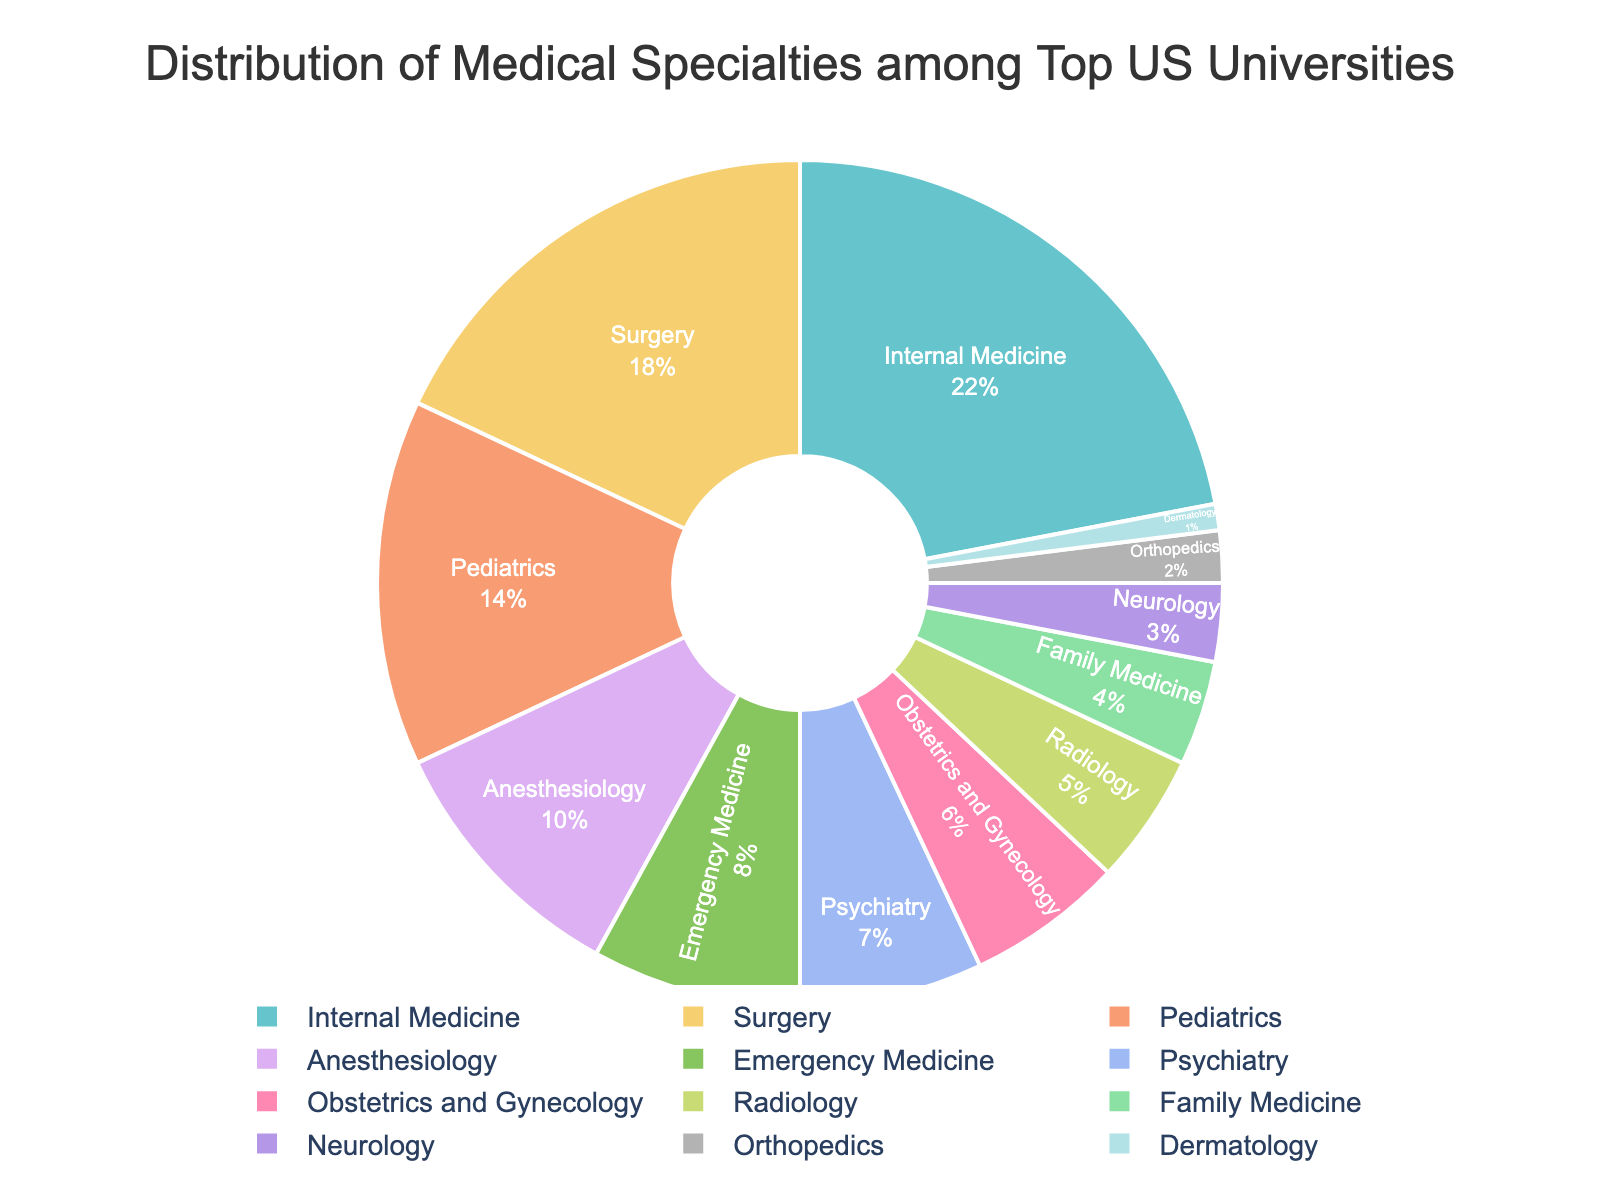Which specialty has the largest representation in the pie chart? The slice of the pie chart labeled "Internal Medicine" is the largest.
Answer: Internal Medicine What is the combined percentage representation of Pediatrics and Anesthesiology specialties? Pediatrics is 14% and Anesthesiology is 10%. Summing these percentages: 14% + 10% = 24%.
Answer: 24% How does the representation of Surgery compare to that of Emergency Medicine? The slice labeled "Surgery" is 18%, while "Emergency Medicine" is 8%. Comparing the two: 18% is greater than 8%.
Answer: Surgery is greater than Emergency Medicine What is the difference in percentage between the most and least represented specialties? Internal Medicine is the most represented at 22%, and Dermatology is the least represented at 1%. The difference is 22% - 1% = 21%.
Answer: 21% Which specialty occupies a bigger portion of the pie, Radiology or Psychiatry? The slice labeled "Psychiatry" is 7%, while "Radiology" is 5%. Comparing the two: 7% is greater than 5%.
Answer: Psychiatry If you combined the percentages of Family Medicine and Neurology, would it be greater than the percentage for Pediatrics? Family Medicine is 4% and Neurology is 3%, combining these: 4% + 3% = 7%. Pediatrics is 14%. Comparing the sums: 7% is less than 14%.
Answer: No What percentage of specialties have a representation of 5% or less? The specialties with 5% or less representation are Radiology (5%), Family Medicine (4%), Neurology (3%), Orthopedics (2%), Dermatology (1%). Summing these: 5 + 4 + 3 + 2 + 1 = 15%. Since there are 12 specialties in total, the percentage is (5/12) * 100 ≈ 42%.
Answer: Approximately 42% Which specialty would you expect to see labeled in the color used for the second smallest slice of the pie chart? The second smallest slice is Orthopedics at 2%, which follows Dermatology at 1%. The color can be deduced visually.
Answer: Orthopedics Are there more specialties represented by a percentage above 10% or below 10%? Specialties above 10%: Internal Medicine (22%), Surgery (18%), Pediatrics (14%), and Anesthesiology (10%) - 4 specialties. Specialties below 10%: Emergency Medicine (8%), Psychiatry (7%), Obstetrics and Gynecology (6%), Radiology (5%), Family Medicine (4%), Neurology (3%), Orthopedics (2%), Dermatology (1%) - 8 specialties.
Answer: Below 10% 